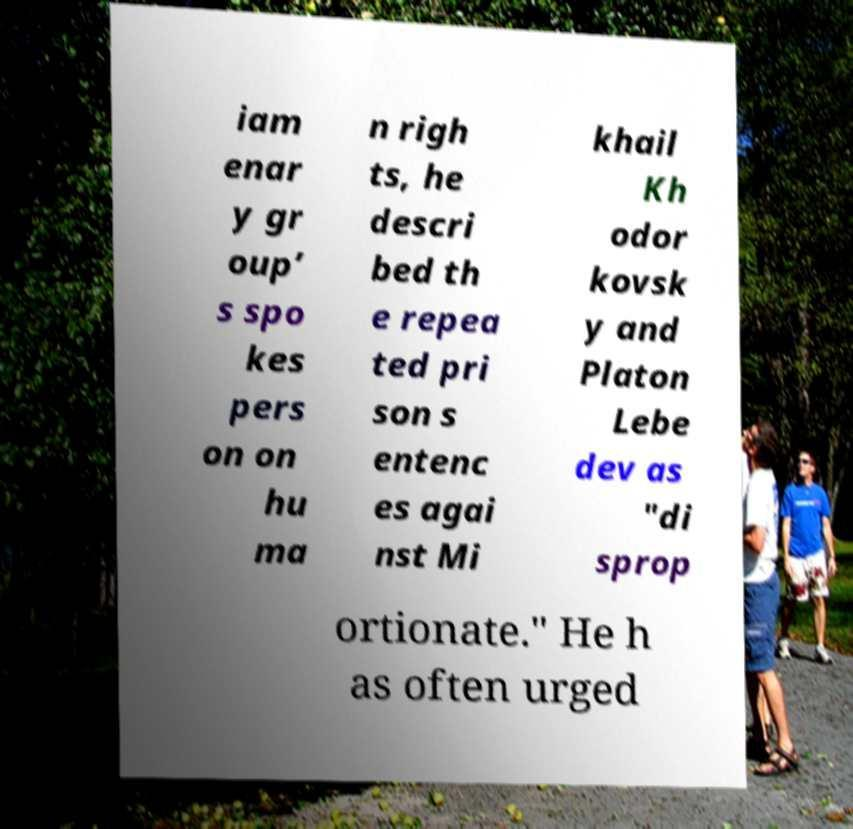Could you assist in decoding the text presented in this image and type it out clearly? iam enar y gr oup’ s spo kes pers on on hu ma n righ ts, he descri bed th e repea ted pri son s entenc es agai nst Mi khail Kh odor kovsk y and Platon Lebe dev as "di sprop ortionate." He h as often urged 